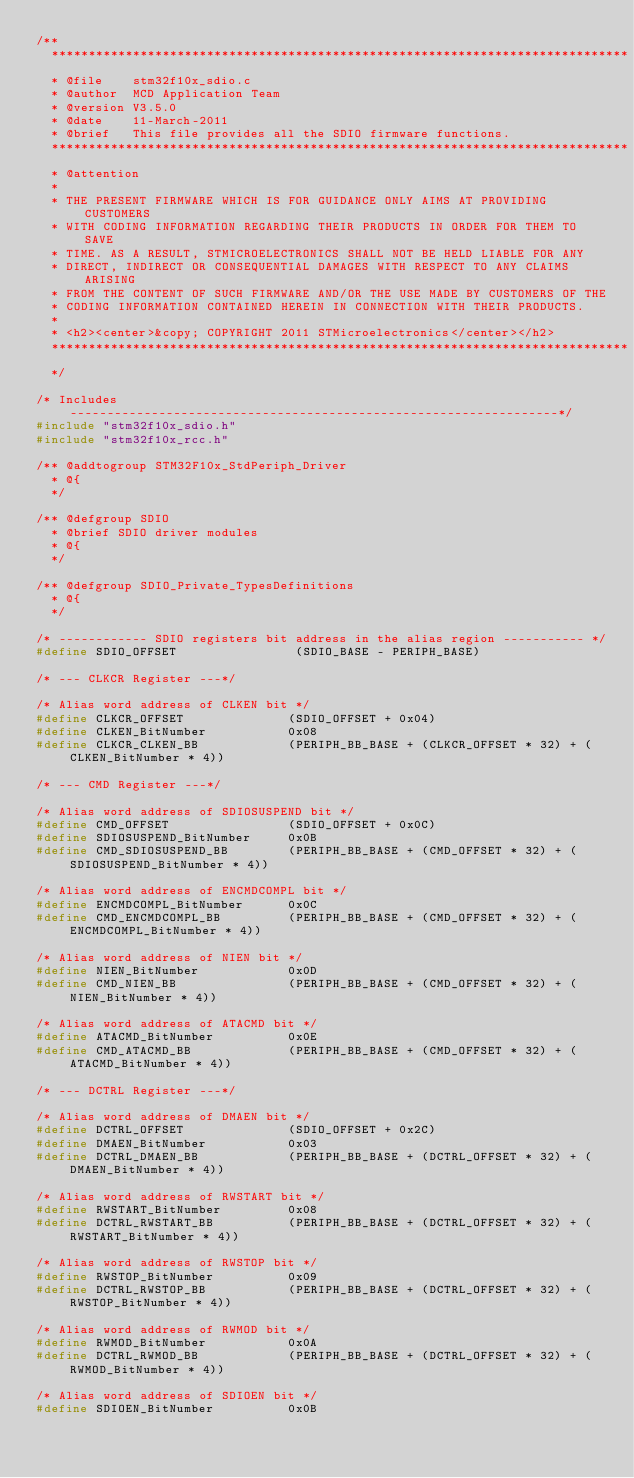<code> <loc_0><loc_0><loc_500><loc_500><_C_>/**
  ******************************************************************************
  * @file    stm32f10x_sdio.c
  * @author  MCD Application Team
  * @version V3.5.0
  * @date    11-March-2011
  * @brief   This file provides all the SDIO firmware functions.
  ******************************************************************************
  * @attention
  *
  * THE PRESENT FIRMWARE WHICH IS FOR GUIDANCE ONLY AIMS AT PROVIDING CUSTOMERS
  * WITH CODING INFORMATION REGARDING THEIR PRODUCTS IN ORDER FOR THEM TO SAVE
  * TIME. AS A RESULT, STMICROELECTRONICS SHALL NOT BE HELD LIABLE FOR ANY
  * DIRECT, INDIRECT OR CONSEQUENTIAL DAMAGES WITH RESPECT TO ANY CLAIMS ARISING
  * FROM THE CONTENT OF SUCH FIRMWARE AND/OR THE USE MADE BY CUSTOMERS OF THE
  * CODING INFORMATION CONTAINED HEREIN IN CONNECTION WITH THEIR PRODUCTS.
  *
  * <h2><center>&copy; COPYRIGHT 2011 STMicroelectronics</center></h2>
  ******************************************************************************
  */

/* Includes ------------------------------------------------------------------*/
#include "stm32f10x_sdio.h"
#include "stm32f10x_rcc.h"

/** @addtogroup STM32F10x_StdPeriph_Driver
  * @{
  */

/** @defgroup SDIO
  * @brief SDIO driver modules
  * @{
  */

/** @defgroup SDIO_Private_TypesDefinitions
  * @{
  */

/* ------------ SDIO registers bit address in the alias region ----------- */
#define SDIO_OFFSET                (SDIO_BASE - PERIPH_BASE)

/* --- CLKCR Register ---*/

/* Alias word address of CLKEN bit */
#define CLKCR_OFFSET              (SDIO_OFFSET + 0x04)
#define CLKEN_BitNumber           0x08
#define CLKCR_CLKEN_BB            (PERIPH_BB_BASE + (CLKCR_OFFSET * 32) + (CLKEN_BitNumber * 4))

/* --- CMD Register ---*/

/* Alias word address of SDIOSUSPEND bit */
#define CMD_OFFSET                (SDIO_OFFSET + 0x0C)
#define SDIOSUSPEND_BitNumber     0x0B
#define CMD_SDIOSUSPEND_BB        (PERIPH_BB_BASE + (CMD_OFFSET * 32) + (SDIOSUSPEND_BitNumber * 4))

/* Alias word address of ENCMDCOMPL bit */
#define ENCMDCOMPL_BitNumber      0x0C
#define CMD_ENCMDCOMPL_BB         (PERIPH_BB_BASE + (CMD_OFFSET * 32) + (ENCMDCOMPL_BitNumber * 4))

/* Alias word address of NIEN bit */
#define NIEN_BitNumber            0x0D
#define CMD_NIEN_BB               (PERIPH_BB_BASE + (CMD_OFFSET * 32) + (NIEN_BitNumber * 4))

/* Alias word address of ATACMD bit */
#define ATACMD_BitNumber          0x0E
#define CMD_ATACMD_BB             (PERIPH_BB_BASE + (CMD_OFFSET * 32) + (ATACMD_BitNumber * 4))

/* --- DCTRL Register ---*/

/* Alias word address of DMAEN bit */
#define DCTRL_OFFSET              (SDIO_OFFSET + 0x2C)
#define DMAEN_BitNumber           0x03
#define DCTRL_DMAEN_BB            (PERIPH_BB_BASE + (DCTRL_OFFSET * 32) + (DMAEN_BitNumber * 4))

/* Alias word address of RWSTART bit */
#define RWSTART_BitNumber         0x08
#define DCTRL_RWSTART_BB          (PERIPH_BB_BASE + (DCTRL_OFFSET * 32) + (RWSTART_BitNumber * 4))

/* Alias word address of RWSTOP bit */
#define RWSTOP_BitNumber          0x09
#define DCTRL_RWSTOP_BB           (PERIPH_BB_BASE + (DCTRL_OFFSET * 32) + (RWSTOP_BitNumber * 4))

/* Alias word address of RWMOD bit */
#define RWMOD_BitNumber           0x0A
#define DCTRL_RWMOD_BB            (PERIPH_BB_BASE + (DCTRL_OFFSET * 32) + (RWMOD_BitNumber * 4))

/* Alias word address of SDIOEN bit */
#define SDIOEN_BitNumber          0x0B</code> 